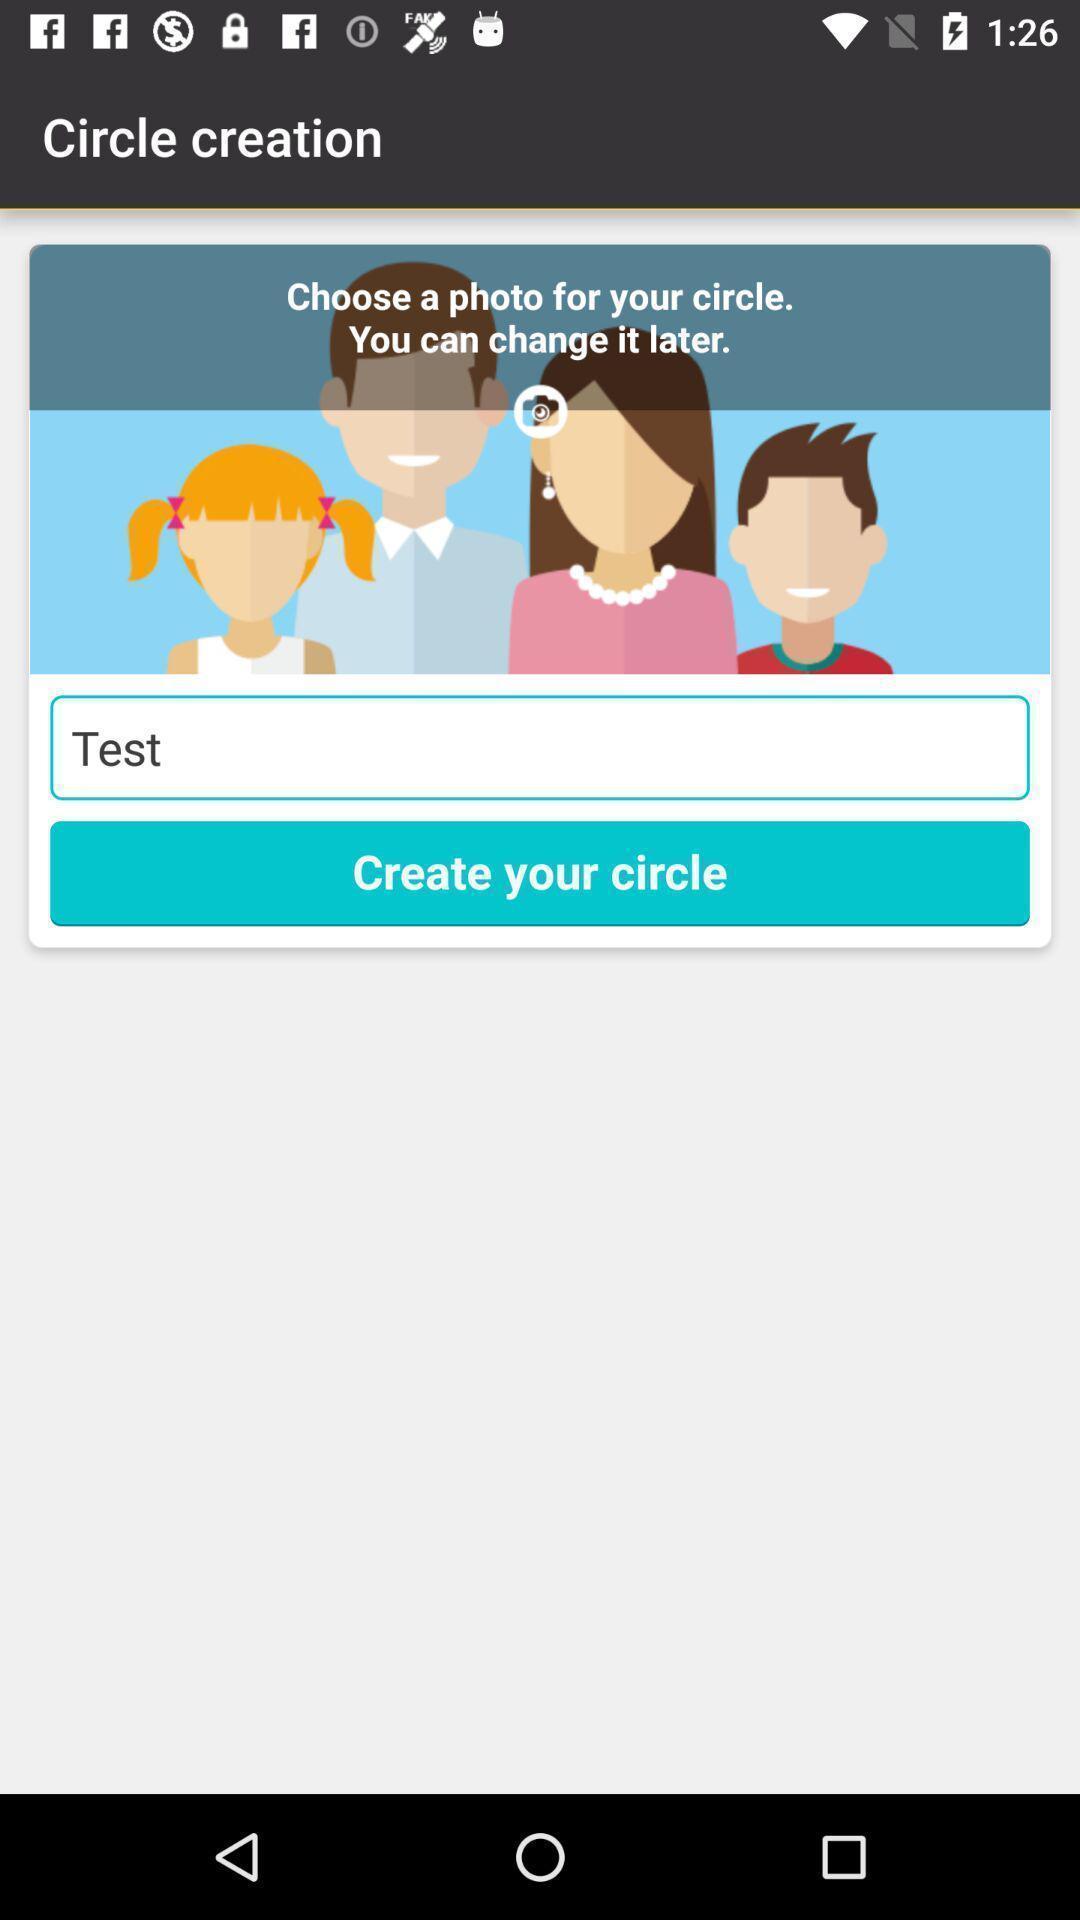Summarize the information in this screenshot. Screen displaying to create an account. 